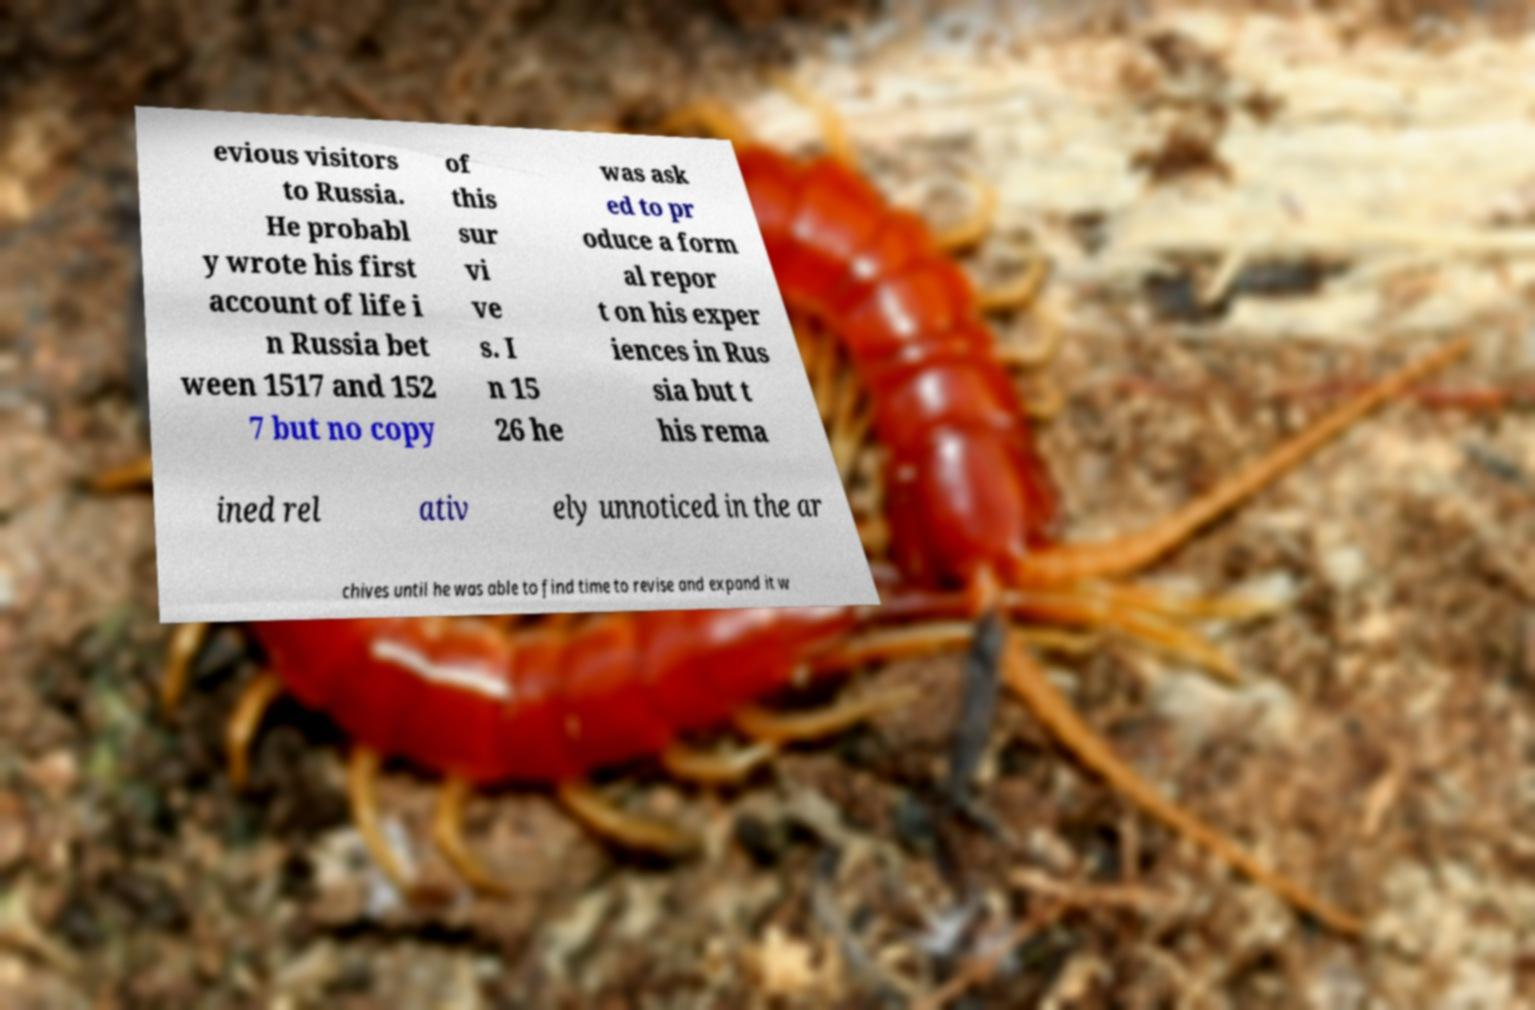What messages or text are displayed in this image? I need them in a readable, typed format. evious visitors to Russia. He probabl y wrote his first account of life i n Russia bet ween 1517 and 152 7 but no copy of this sur vi ve s. I n 15 26 he was ask ed to pr oduce a form al repor t on his exper iences in Rus sia but t his rema ined rel ativ ely unnoticed in the ar chives until he was able to find time to revise and expand it w 